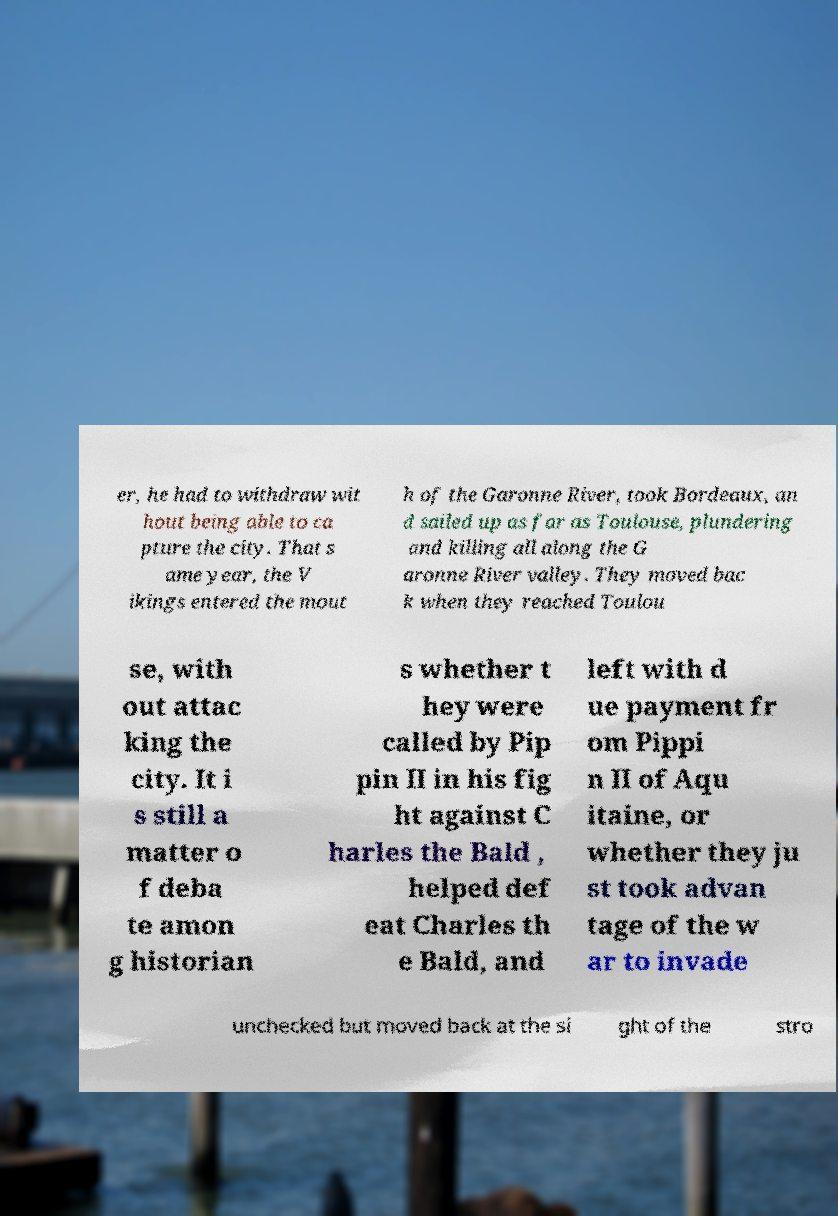For documentation purposes, I need the text within this image transcribed. Could you provide that? er, he had to withdraw wit hout being able to ca pture the city. That s ame year, the V ikings entered the mout h of the Garonne River, took Bordeaux, an d sailed up as far as Toulouse, plundering and killing all along the G aronne River valley. They moved bac k when they reached Toulou se, with out attac king the city. It i s still a matter o f deba te amon g historian s whether t hey were called by Pip pin II in his fig ht against C harles the Bald , helped def eat Charles th e Bald, and left with d ue payment fr om Pippi n II of Aqu itaine, or whether they ju st took advan tage of the w ar to invade unchecked but moved back at the si ght of the stro 